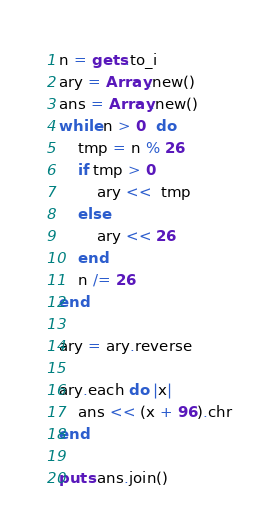<code> <loc_0><loc_0><loc_500><loc_500><_Ruby_>n = gets.to_i
ary = Array.new()
ans = Array.new()
while n > 0  do
    tmp = n % 26
    if tmp > 0
        ary <<  tmp
    else
        ary << 26
    end
    n /= 26
end

ary = ary.reverse

ary.each do |x|
    ans << (x + 96).chr
end

puts ans.join()

</code> 